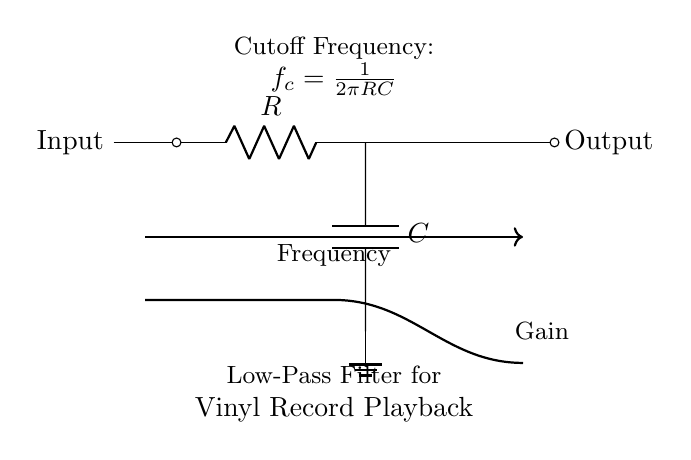What type of filter is represented in this circuit? This circuit diagram shows a low-pass filter, indicated by the presence of a resistor and a capacitor in a specific configuration that allows low frequencies to pass while attenuating higher frequencies.
Answer: Low-pass filter What components are present in the circuit? The circuit consists of a resistor and a capacitor, which are labeled as R and C respectively. These components are crucial for forming the filter.
Answer: Resistor and capacitor What is the cutoff frequency formula provided in the circuit? The circuit diagram specifies the cutoff frequency formula as f_c = 1/(2πRC), where R is the resistance and C is the capacitance, determining at which frequency the output starts to decrease.
Answer: f_c = 1/(2πRC) What happens to high-frequency signals in this circuit? High-frequency signals are attenuated or reduced as they approach the cutoff frequency, meaning the output signal level decreases for these frequencies as they do not pass effectively through the circuit.
Answer: Attenuated How does changing the resistance (R) affect the cutoff frequency? Increasing the resistance (R) will lower the cutoff frequency (f_c) according to the formula, meaning the filter will pass fewer higher frequencies while allowing lower frequencies to pass more freely.
Answer: Lowers cutoff frequency What is the output of this circuit compared to the input at the cutoff frequency? At the cutoff frequency, the output will be approximately 70.7% of the input voltage, which is a key characteristic of low-pass filters in terms of gain reduction at this specific frequency.
Answer: 70.7% of input voltage 